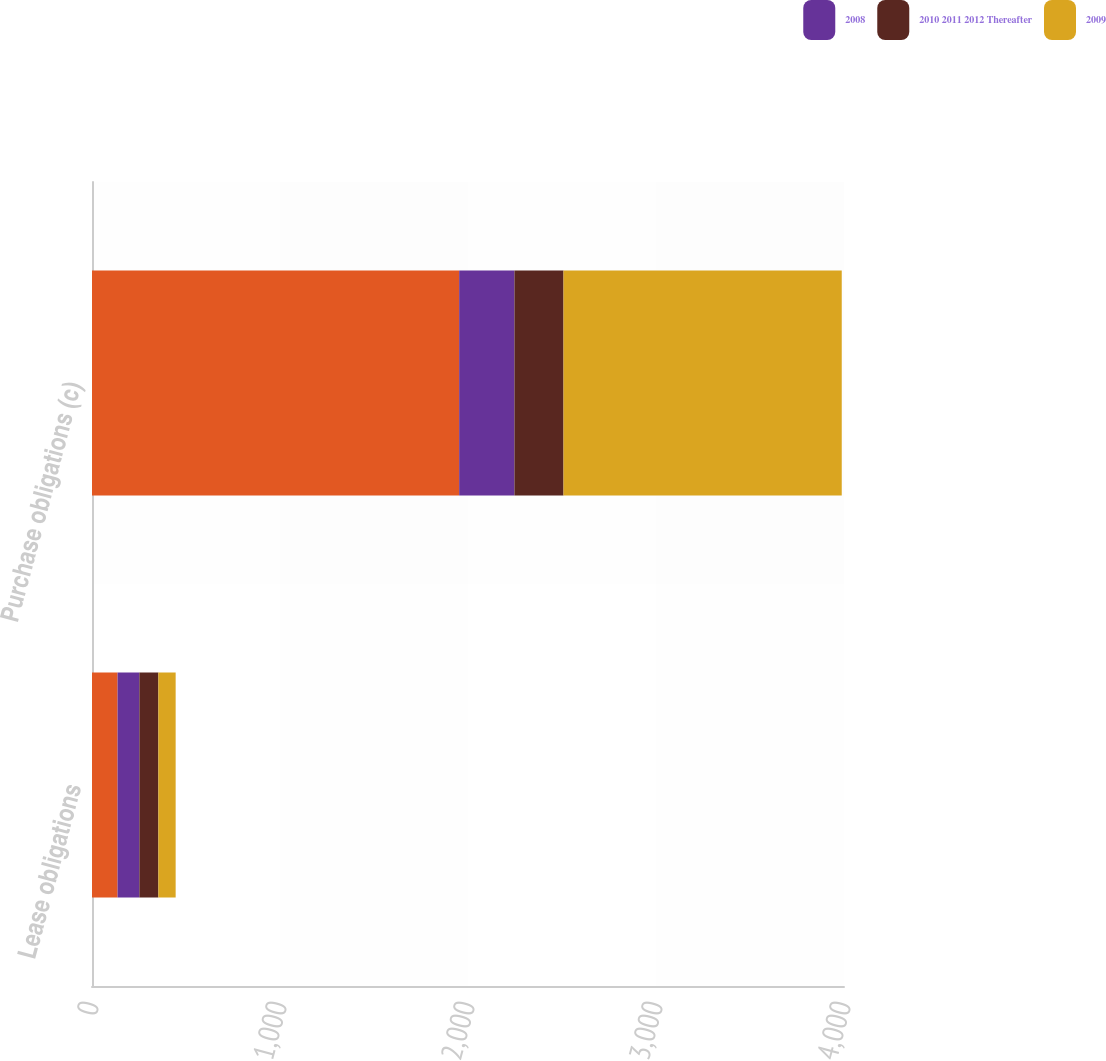Convert chart to OTSL. <chart><loc_0><loc_0><loc_500><loc_500><stacked_bar_chart><ecel><fcel>Lease obligations<fcel>Purchase obligations (c)<nl><fcel>nan<fcel>136<fcel>1953<nl><fcel>2008<fcel>116<fcel>294<nl><fcel>2010 2011 2012 Thereafter<fcel>101<fcel>261<nl><fcel>2009<fcel>92<fcel>1480<nl></chart> 